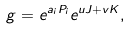Convert formula to latex. <formula><loc_0><loc_0><loc_500><loc_500>g = e ^ { a _ { i } P _ { i } } e ^ { u J + v K } ,</formula> 